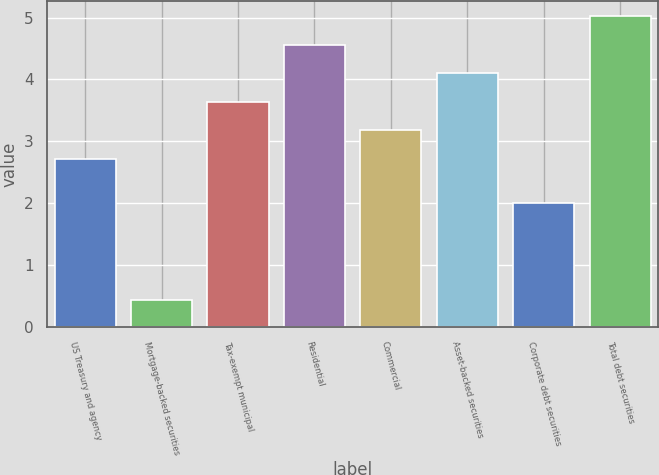Convert chart to OTSL. <chart><loc_0><loc_0><loc_500><loc_500><bar_chart><fcel>US Treasury and agency<fcel>Mortgage-backed securities<fcel>Tax-exempt municipal<fcel>Residential<fcel>Commercial<fcel>Asset-backed securities<fcel>Corporate debt securities<fcel>Total debt securities<nl><fcel>2.72<fcel>0.44<fcel>3.64<fcel>4.56<fcel>3.18<fcel>4.1<fcel>2<fcel>5.02<nl></chart> 